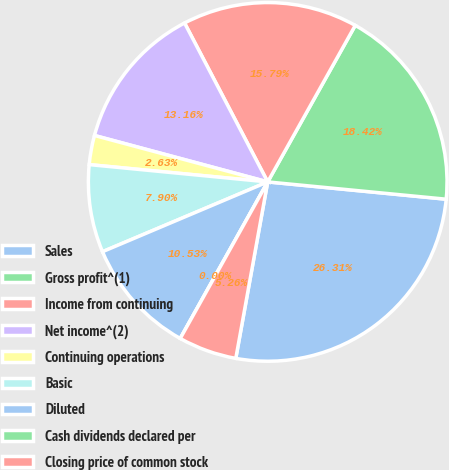Convert chart to OTSL. <chart><loc_0><loc_0><loc_500><loc_500><pie_chart><fcel>Sales<fcel>Gross profit^(1)<fcel>Income from continuing<fcel>Net income^(2)<fcel>Continuing operations<fcel>Basic<fcel>Diluted<fcel>Cash dividends declared per<fcel>Closing price of common stock<nl><fcel>26.31%<fcel>18.42%<fcel>15.79%<fcel>13.16%<fcel>2.63%<fcel>7.9%<fcel>10.53%<fcel>0.0%<fcel>5.26%<nl></chart> 